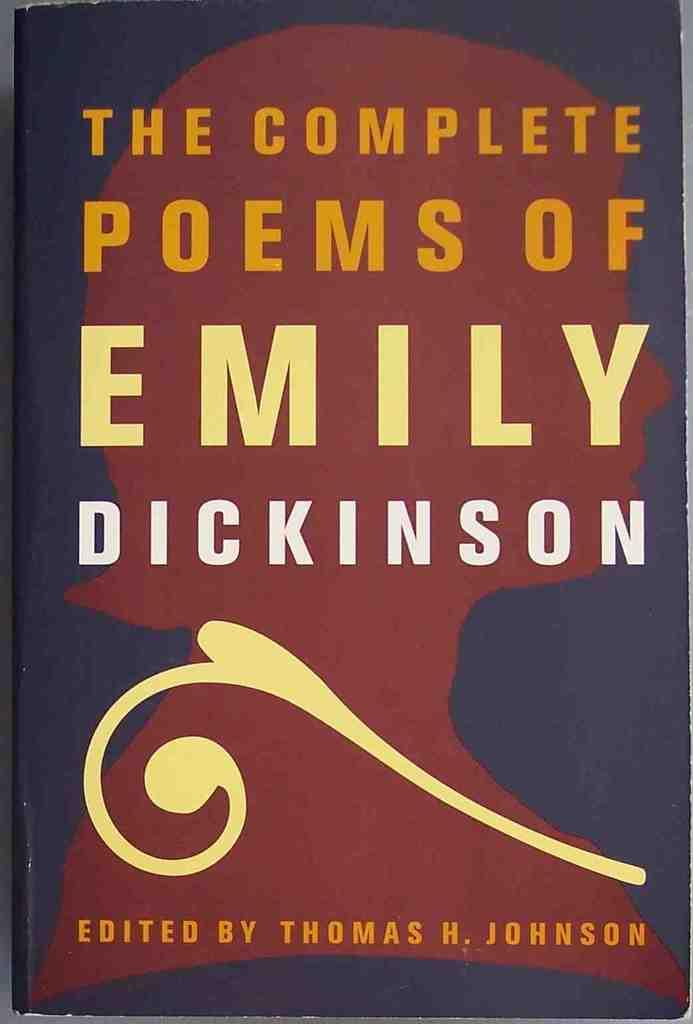<image>
Share a concise interpretation of the image provided. A book cover of a book that was edited by someone named Thomas. 